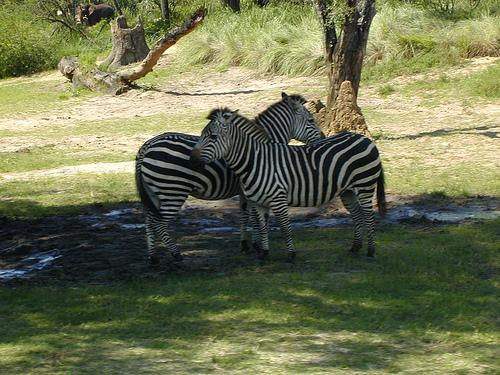Describe the interaction between the two zebras in the image and their immediate surroundings. The two zebras stand close together, with one facing left and the other facing right, on a mix of green and brown grass, surrounded by wet muddy trails and shadows on the ground. In this image, what elements provide a sense of nature and movement? The elements which provide a sense of nature include the two zebras, the green and brown grass, tree trunk, broken tree branch, and green plants on the ground, while water running through the field creates a sense of movement. Describe the image focusing on the condition of the environment around the zebras. The zebras are standing in a field with green and brown grass, long grass, wet muddy trails, and broken tree branches. The shadow of a tree branch is also apparent on the grass. Identify three features of the image that could be used to create a mood or atmosphere. The water running through the field, the long grass, and the shadow of a tree branch can create a sense of calm, tranquility, and peacefulness in the image. Examine the image and determine whether or not it has any conflicting elements. The image does not have any conflicting elements, as the field setting, zebras, plants, and broken tree parts all contribute to a harmonious and natural scene. Explain the landscape setting of the image, emphasizing any significant objects and features. The image shows a field with a mix of green and brown grass, long grass, and wet muddy trails. There is a shadow of a tree branch and green plants on the ground. A broken tree branch, stump, and trunk are also present. What signs of life can be seen in this image? Two zebras are standing together, one facing left and the other facing right, in a field with green and brown grass. An elephant can be seen in the background. What are the distinguishing characteristics of the zebras in the image? The zebras in the image have black and white stripes, a thick mane on their necks, black tails, black hoofs, and black eyes. The manes are also white and black. Provide a detailed description of the animals present in the image. There are two zebras standing close to each other, each with black and white stripes, a fluffy mane, a black tail, and black hoofs; one is facing to the left and the other to the right. What unifying theme pervades the image, and what gives evidence to this theme? The unifying theme of the image is an intimate encounter between two zebras in their natural habitat. Evidence of this theme includes the close proximity of the zebras, the natural environment of grass and muddy trails, and the overall calm atmosphere. 